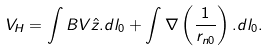<formula> <loc_0><loc_0><loc_500><loc_500>V _ { H } = \int B V \hat { z } . d l _ { 0 } + \int \nabla \left ( \frac { 1 } { r _ { n 0 } } \right ) . d l _ { 0 } .</formula> 